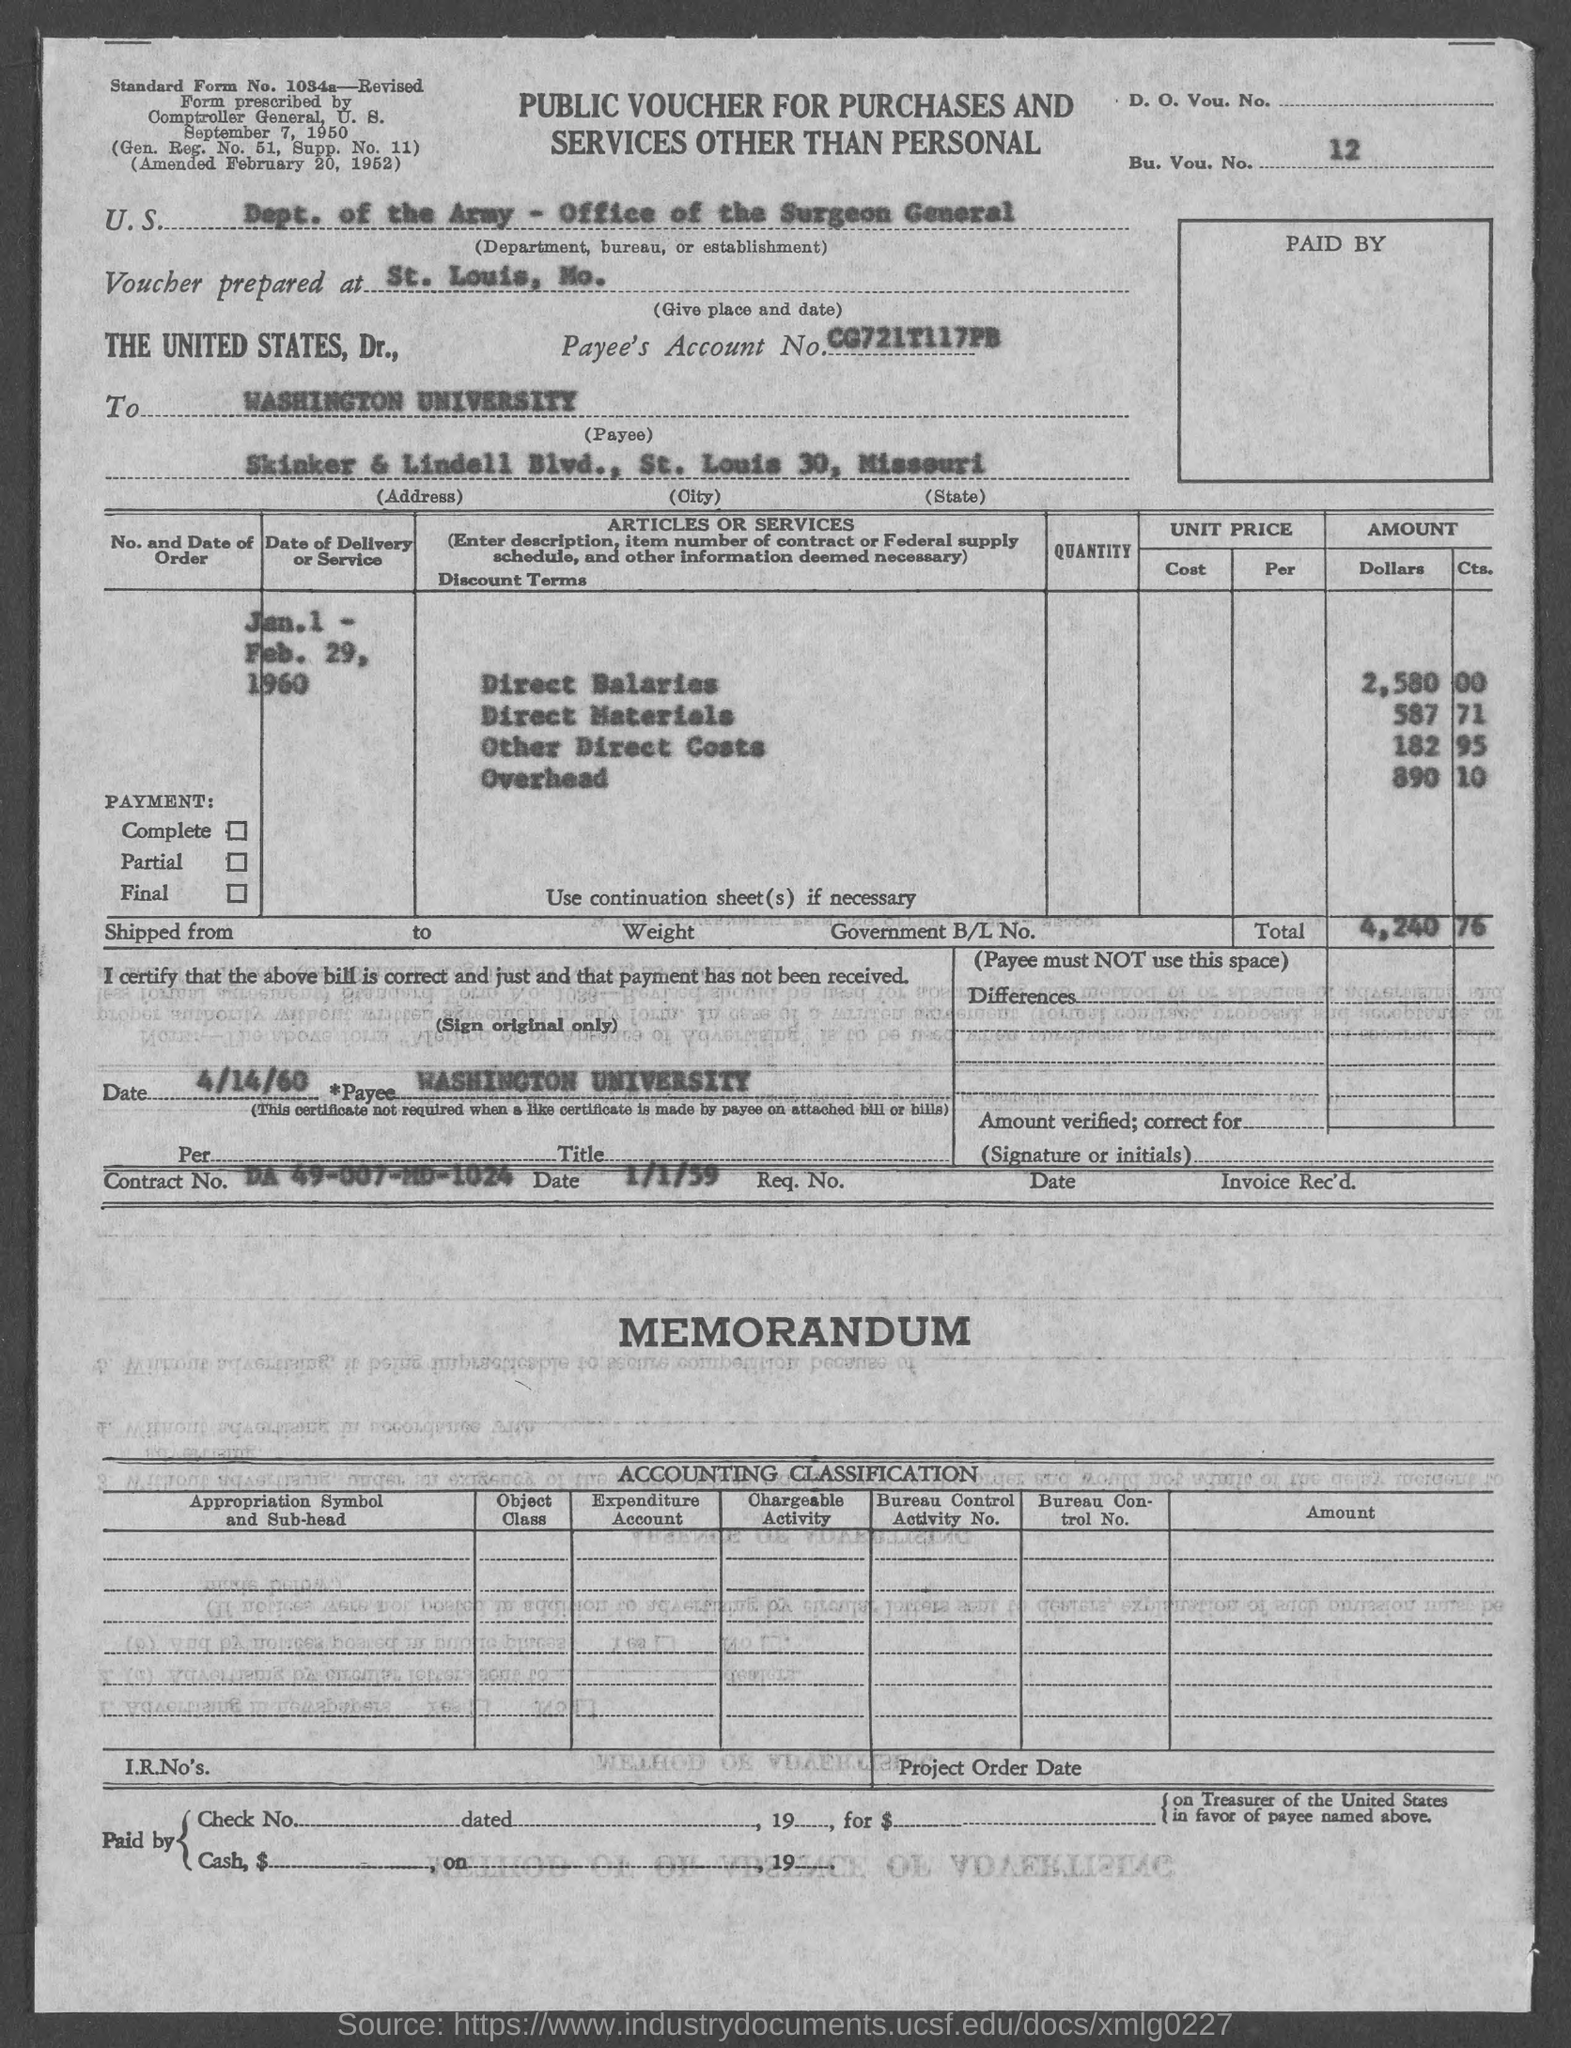What is the Bu. Vou. No.?
Provide a short and direct response. 12. Where is The voucher is prepared at ?
Ensure brevity in your answer.  St. Louis, Mo. What is the Payee's Account No.?
Your response must be concise. Cg721t117pb. What is the Payee Address?
Give a very brief answer. Skinker & lindell blvd. What is the Payee City?
Your response must be concise. St. louis 30. What is the Payee State?
Keep it short and to the point. Missouri. What is the Direct Salaries amount?
Offer a very short reply. 2,580.00. What is the Direct Materials amount?
Provide a short and direct response. 587 71. What is the Other Direct Costs amount?
Your answer should be very brief. 182 95. What is the Total amount?
Offer a very short reply. 4,240.76. 